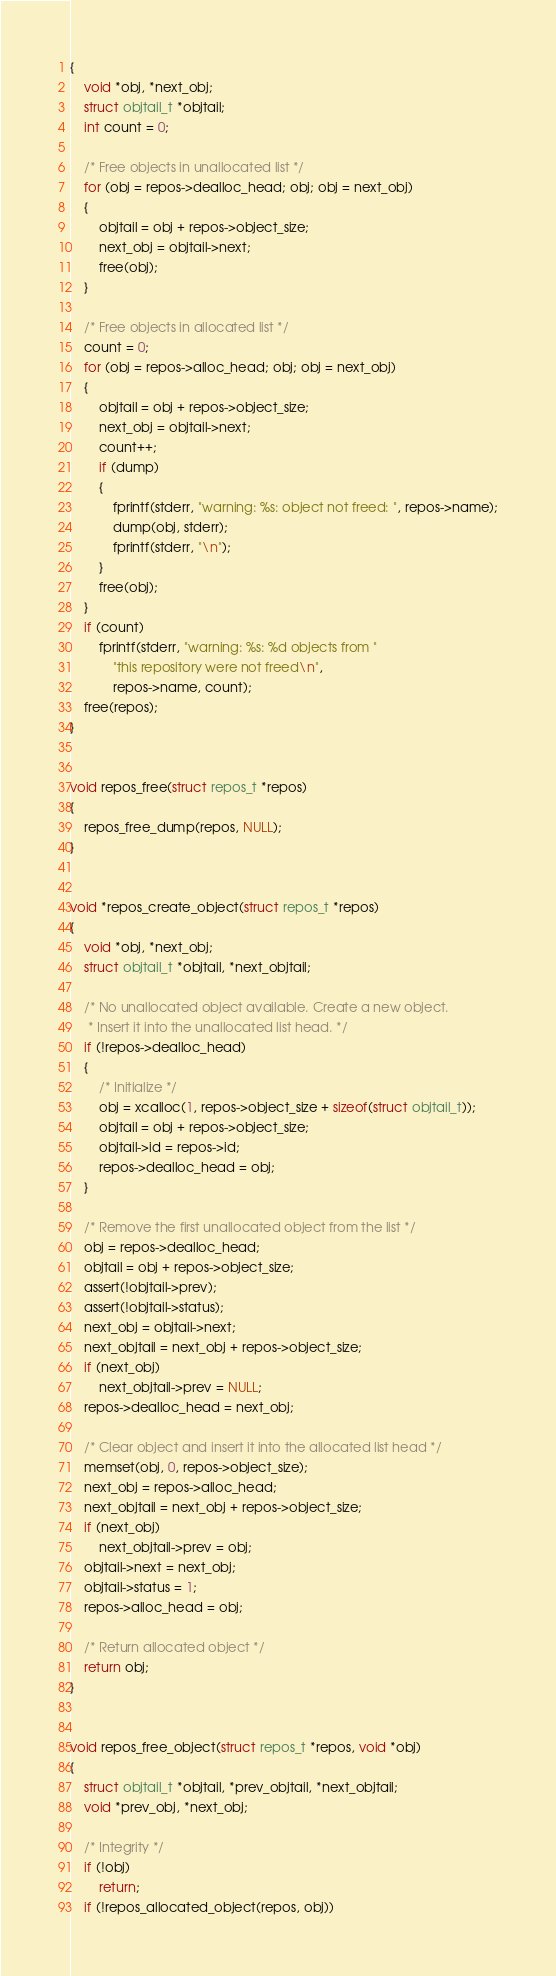Convert code to text. <code><loc_0><loc_0><loc_500><loc_500><_C_>{
	void *obj, *next_obj;
	struct objtail_t *objtail;
	int count = 0;

	/* Free objects in unallocated list */
	for (obj = repos->dealloc_head; obj; obj = next_obj)
	{
		objtail = obj + repos->object_size;
		next_obj = objtail->next;
		free(obj);
	}

	/* Free objects in allocated list */
	count = 0;
	for (obj = repos->alloc_head; obj; obj = next_obj)
	{
		objtail = obj + repos->object_size;
		next_obj = objtail->next;
		count++;
		if (dump)
		{
			fprintf(stderr, "warning: %s: object not freed: ", repos->name);
			dump(obj, stderr);
			fprintf(stderr, "\n");
		}
		free(obj);
	}
	if (count)
		fprintf(stderr, "warning: %s: %d objects from "
			"this repository were not freed\n",
			repos->name, count);
	free(repos);
}


void repos_free(struct repos_t *repos)
{
	repos_free_dump(repos, NULL);
}


void *repos_create_object(struct repos_t *repos)
{
	void *obj, *next_obj;
	struct objtail_t *objtail, *next_objtail;
	
	/* No unallocated object available. Create a new object.
	 * Insert it into the unallocated list head. */
	if (!repos->dealloc_head)
	{
		/* Initialize */
		obj = xcalloc(1, repos->object_size + sizeof(struct objtail_t));
		objtail = obj + repos->object_size;
		objtail->id = repos->id;
		repos->dealloc_head = obj;
	}

	/* Remove the first unallocated object from the list */
	obj = repos->dealloc_head;
	objtail = obj + repos->object_size;
	assert(!objtail->prev);
	assert(!objtail->status);
	next_obj = objtail->next;
	next_objtail = next_obj + repos->object_size;
	if (next_obj)
		next_objtail->prev = NULL;
	repos->dealloc_head = next_obj;

	/* Clear object and insert it into the allocated list head */
	memset(obj, 0, repos->object_size);
	next_obj = repos->alloc_head;
	next_objtail = next_obj + repos->object_size;
	if (next_obj)
		next_objtail->prev = obj;
	objtail->next = next_obj;
	objtail->status = 1;
	repos->alloc_head = obj;

	/* Return allocated object */
	return obj;
}


void repos_free_object(struct repos_t *repos, void *obj)
{
	struct objtail_t *objtail, *prev_objtail, *next_objtail;
	void *prev_obj, *next_obj;
	
	/* Integrity */
	if (!obj)
		return;
	if (!repos_allocated_object(repos, obj))</code> 